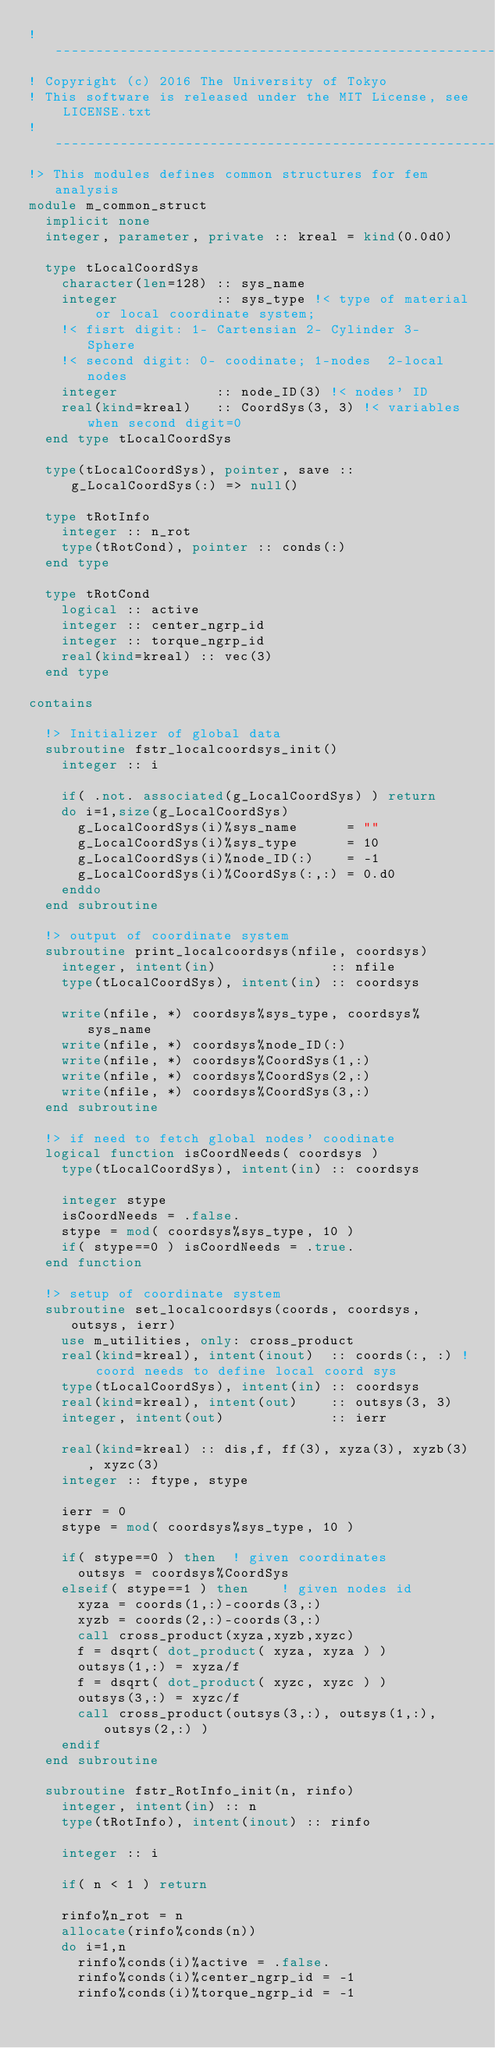<code> <loc_0><loc_0><loc_500><loc_500><_FORTRAN_>!-------------------------------------------------------------------------------
! Copyright (c) 2016 The University of Tokyo
! This software is released under the MIT License, see LICENSE.txt
!-------------------------------------------------------------------------------
!> This modules defines common structures for fem analysis
module m_common_struct
  implicit none
  integer, parameter, private :: kreal = kind(0.0d0)

  type tLocalCoordSys
    character(len=128) :: sys_name
    integer            :: sys_type !< type of material or local coordinate system;
    !< fisrt digit: 1- Cartensian 2- Cylinder 3- Sphere
    !< second digit: 0- coodinate; 1-nodes  2-local nodes
    integer            :: node_ID(3) !< nodes' ID
    real(kind=kreal)   :: CoordSys(3, 3) !< variables when second digit=0
  end type tLocalCoordSys

  type(tLocalCoordSys), pointer, save :: g_LocalCoordSys(:) => null()

  type tRotInfo
    integer :: n_rot
    type(tRotCond), pointer :: conds(:)
  end type

  type tRotCond
    logical :: active
    integer :: center_ngrp_id
    integer :: torque_ngrp_id
    real(kind=kreal) :: vec(3)
  end type

contains

  !> Initializer of global data
  subroutine fstr_localcoordsys_init()
    integer :: i

    if( .not. associated(g_LocalCoordSys) ) return
    do i=1,size(g_LocalCoordSys)
      g_LocalCoordSys(i)%sys_name      = ""
      g_LocalCoordSys(i)%sys_type      = 10
      g_LocalCoordSys(i)%node_ID(:)    = -1
      g_LocalCoordSys(i)%CoordSys(:,:) = 0.d0
    enddo
  end subroutine

  !> output of coordinate system
  subroutine print_localcoordsys(nfile, coordsys)
    integer, intent(in)              :: nfile
    type(tLocalCoordSys), intent(in) :: coordsys

    write(nfile, *) coordsys%sys_type, coordsys%sys_name
    write(nfile, *) coordsys%node_ID(:)
    write(nfile, *) coordsys%CoordSys(1,:)
    write(nfile, *) coordsys%CoordSys(2,:)
    write(nfile, *) coordsys%CoordSys(3,:)
  end subroutine

  !> if need to fetch global nodes' coodinate
  logical function isCoordNeeds( coordsys )
    type(tLocalCoordSys), intent(in) :: coordsys

    integer stype
    isCoordNeeds = .false.
    stype = mod( coordsys%sys_type, 10 )
    if( stype==0 ) isCoordNeeds = .true.
  end function

  !> setup of coordinate system
  subroutine set_localcoordsys(coords, coordsys, outsys, ierr)
    use m_utilities, only: cross_product
    real(kind=kreal), intent(inout)  :: coords(:, :) ! coord needs to define local coord sys
    type(tLocalCoordSys), intent(in) :: coordsys
    real(kind=kreal), intent(out)    :: outsys(3, 3)
    integer, intent(out)             :: ierr

    real(kind=kreal) :: dis,f, ff(3), xyza(3), xyzb(3), xyzc(3)
    integer :: ftype, stype

    ierr = 0
    stype = mod( coordsys%sys_type, 10 )

    if( stype==0 ) then  ! given coordinates
      outsys = coordsys%CoordSys
    elseif( stype==1 ) then    ! given nodes id
      xyza = coords(1,:)-coords(3,:)
      xyzb = coords(2,:)-coords(3,:)
      call cross_product(xyza,xyzb,xyzc)
      f = dsqrt( dot_product( xyza, xyza ) )
      outsys(1,:) = xyza/f
      f = dsqrt( dot_product( xyzc, xyzc ) )
      outsys(3,:) = xyzc/f
      call cross_product(outsys(3,:), outsys(1,:), outsys(2,:) )
    endif
  end subroutine

  subroutine fstr_RotInfo_init(n, rinfo)
    integer, intent(in) :: n
    type(tRotInfo), intent(inout) :: rinfo

    integer :: i

    if( n < 1 ) return

    rinfo%n_rot = n
    allocate(rinfo%conds(n))
    do i=1,n
      rinfo%conds(i)%active = .false.
      rinfo%conds(i)%center_ngrp_id = -1
      rinfo%conds(i)%torque_ngrp_id = -1</code> 